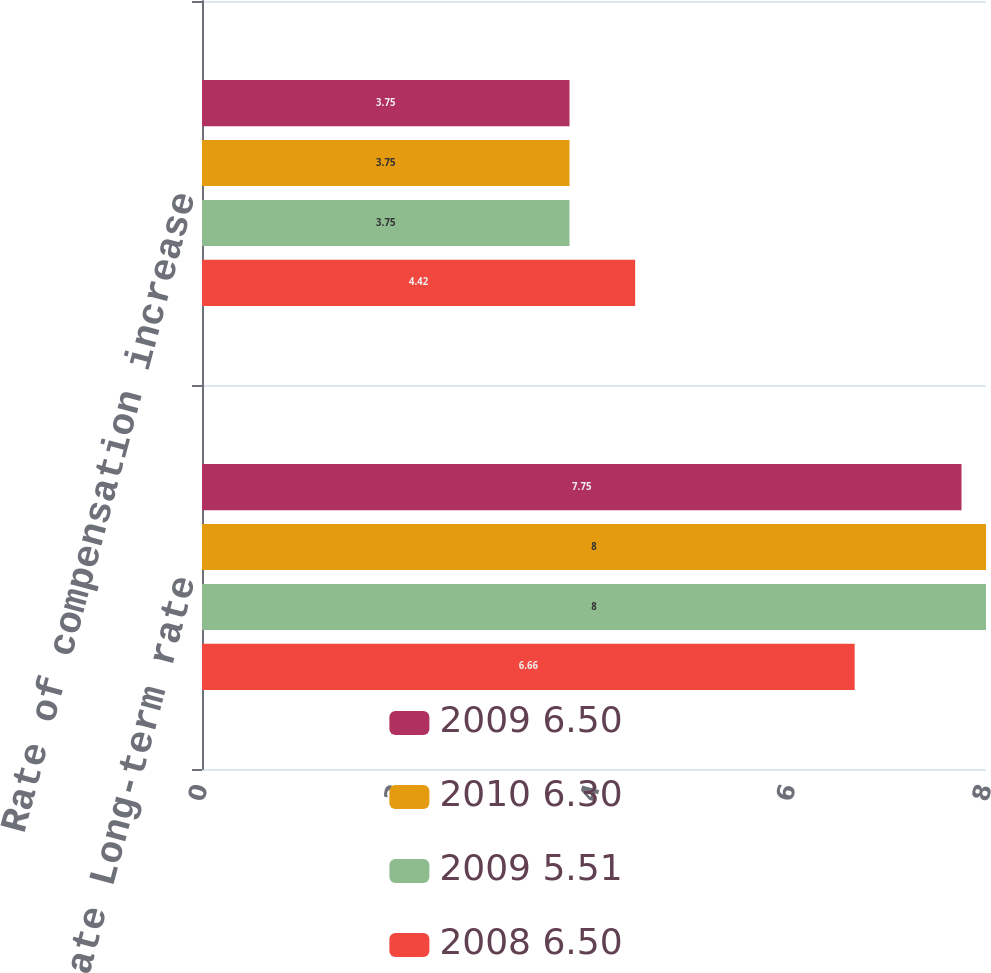Convert chart. <chart><loc_0><loc_0><loc_500><loc_500><stacked_bar_chart><ecel><fcel>Discount rate Long-term rate<fcel>Rate of compensation increase<nl><fcel>2009 6.50<fcel>7.75<fcel>3.75<nl><fcel>2010 6.30<fcel>8<fcel>3.75<nl><fcel>2009 5.51<fcel>8<fcel>3.75<nl><fcel>2008 6.50<fcel>6.66<fcel>4.42<nl></chart> 